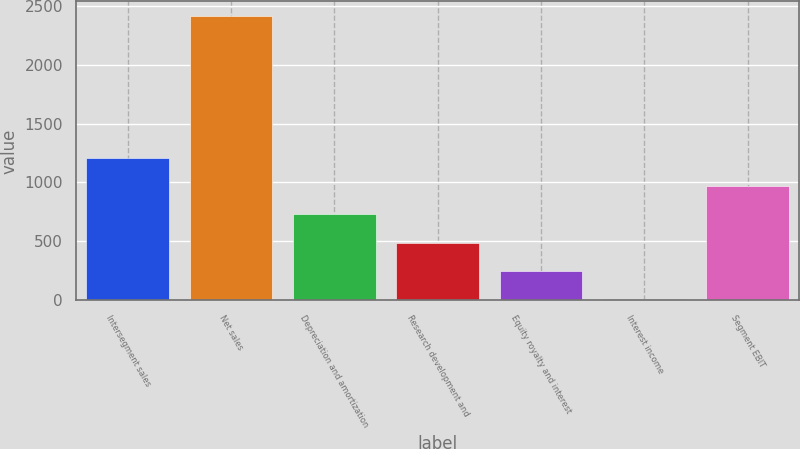<chart> <loc_0><loc_0><loc_500><loc_500><bar_chart><fcel>Intersegment sales<fcel>Net sales<fcel>Depreciation and amortization<fcel>Research development and<fcel>Equity royalty and interest<fcel>Interest income<fcel>Segment EBIT<nl><fcel>1211.5<fcel>2416<fcel>729.7<fcel>488.8<fcel>247.9<fcel>7<fcel>970.6<nl></chart> 